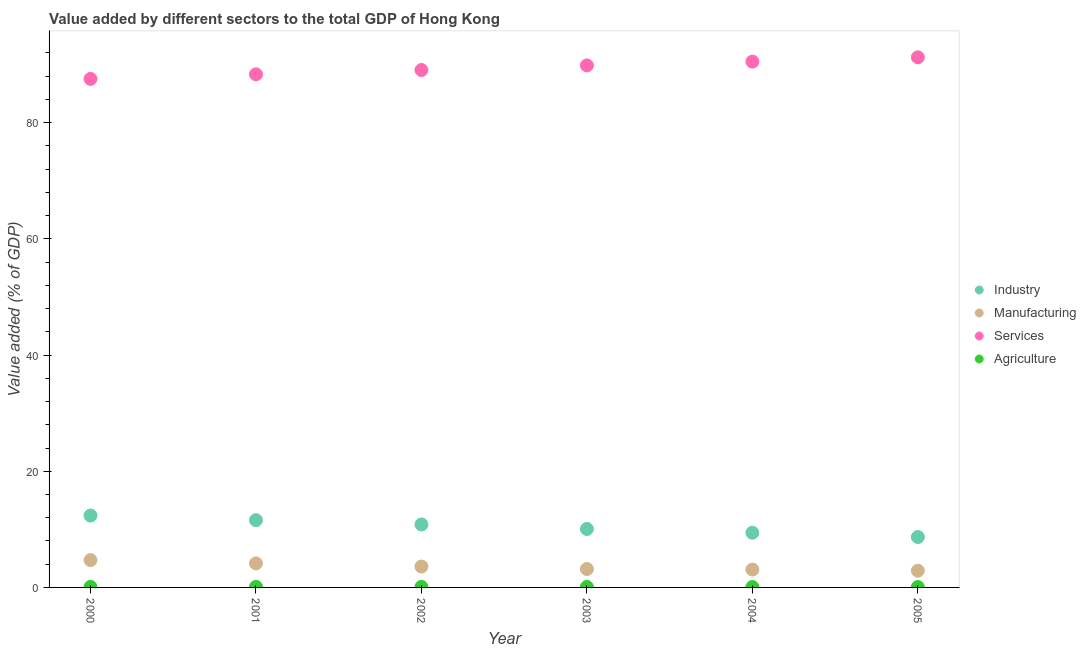Is the number of dotlines equal to the number of legend labels?
Offer a terse response. Yes. What is the value added by manufacturing sector in 2005?
Your answer should be compact. 2.88. Across all years, what is the maximum value added by services sector?
Your answer should be very brief. 91.26. Across all years, what is the minimum value added by agricultural sector?
Keep it short and to the point. 0.07. In which year was the value added by industrial sector maximum?
Give a very brief answer. 2000. What is the total value added by services sector in the graph?
Keep it short and to the point. 536.57. What is the difference between the value added by agricultural sector in 2001 and that in 2003?
Your answer should be compact. 0.01. What is the difference between the value added by industrial sector in 2002 and the value added by manufacturing sector in 2005?
Provide a short and direct response. 7.96. What is the average value added by services sector per year?
Keep it short and to the point. 89.43. In the year 2005, what is the difference between the value added by services sector and value added by manufacturing sector?
Your response must be concise. 88.38. In how many years, is the value added by services sector greater than 16 %?
Your answer should be compact. 6. What is the ratio of the value added by agricultural sector in 2000 to that in 2002?
Your response must be concise. 1. Is the difference between the value added by agricultural sector in 2003 and 2005 greater than the difference between the value added by manufacturing sector in 2003 and 2005?
Provide a succinct answer. No. What is the difference between the highest and the second highest value added by manufacturing sector?
Your answer should be compact. 0.56. What is the difference between the highest and the lowest value added by manufacturing sector?
Make the answer very short. 1.82. Does the value added by agricultural sector monotonically increase over the years?
Your response must be concise. No. Is the value added by manufacturing sector strictly greater than the value added by industrial sector over the years?
Give a very brief answer. No. How many dotlines are there?
Ensure brevity in your answer.  4. What is the difference between two consecutive major ticks on the Y-axis?
Your answer should be very brief. 20. Does the graph contain any zero values?
Offer a terse response. No. Where does the legend appear in the graph?
Provide a succinct answer. Center right. What is the title of the graph?
Provide a succinct answer. Value added by different sectors to the total GDP of Hong Kong. What is the label or title of the X-axis?
Provide a short and direct response. Year. What is the label or title of the Y-axis?
Offer a terse response. Value added (% of GDP). What is the Value added (% of GDP) in Industry in 2000?
Your answer should be very brief. 12.37. What is the Value added (% of GDP) in Manufacturing in 2000?
Ensure brevity in your answer.  4.7. What is the Value added (% of GDP) in Services in 2000?
Your answer should be compact. 87.54. What is the Value added (% of GDP) of Agriculture in 2000?
Provide a short and direct response. 0.09. What is the Value added (% of GDP) of Industry in 2001?
Offer a terse response. 11.58. What is the Value added (% of GDP) of Manufacturing in 2001?
Your answer should be compact. 4.14. What is the Value added (% of GDP) in Services in 2001?
Make the answer very short. 88.33. What is the Value added (% of GDP) in Agriculture in 2001?
Give a very brief answer. 0.09. What is the Value added (% of GDP) of Industry in 2002?
Give a very brief answer. 10.84. What is the Value added (% of GDP) in Manufacturing in 2002?
Give a very brief answer. 3.6. What is the Value added (% of GDP) of Services in 2002?
Give a very brief answer. 89.07. What is the Value added (% of GDP) of Agriculture in 2002?
Your answer should be very brief. 0.09. What is the Value added (% of GDP) in Industry in 2003?
Give a very brief answer. 10.06. What is the Value added (% of GDP) of Manufacturing in 2003?
Your answer should be compact. 3.17. What is the Value added (% of GDP) of Services in 2003?
Provide a short and direct response. 89.86. What is the Value added (% of GDP) of Agriculture in 2003?
Your answer should be compact. 0.08. What is the Value added (% of GDP) in Industry in 2004?
Provide a short and direct response. 9.41. What is the Value added (% of GDP) of Manufacturing in 2004?
Your response must be concise. 3.07. What is the Value added (% of GDP) of Services in 2004?
Give a very brief answer. 90.51. What is the Value added (% of GDP) of Agriculture in 2004?
Your response must be concise. 0.08. What is the Value added (% of GDP) of Industry in 2005?
Offer a terse response. 8.67. What is the Value added (% of GDP) in Manufacturing in 2005?
Offer a very short reply. 2.88. What is the Value added (% of GDP) in Services in 2005?
Provide a succinct answer. 91.26. What is the Value added (% of GDP) of Agriculture in 2005?
Your answer should be compact. 0.07. Across all years, what is the maximum Value added (% of GDP) of Industry?
Make the answer very short. 12.37. Across all years, what is the maximum Value added (% of GDP) of Manufacturing?
Your response must be concise. 4.7. Across all years, what is the maximum Value added (% of GDP) of Services?
Keep it short and to the point. 91.26. Across all years, what is the maximum Value added (% of GDP) of Agriculture?
Give a very brief answer. 0.09. Across all years, what is the minimum Value added (% of GDP) of Industry?
Ensure brevity in your answer.  8.67. Across all years, what is the minimum Value added (% of GDP) of Manufacturing?
Ensure brevity in your answer.  2.88. Across all years, what is the minimum Value added (% of GDP) in Services?
Your answer should be compact. 87.54. Across all years, what is the minimum Value added (% of GDP) in Agriculture?
Your answer should be very brief. 0.07. What is the total Value added (% of GDP) in Industry in the graph?
Keep it short and to the point. 62.94. What is the total Value added (% of GDP) of Manufacturing in the graph?
Keep it short and to the point. 21.56. What is the total Value added (% of GDP) in Services in the graph?
Give a very brief answer. 536.57. What is the total Value added (% of GDP) of Agriculture in the graph?
Your answer should be compact. 0.49. What is the difference between the Value added (% of GDP) of Industry in 2000 and that in 2001?
Keep it short and to the point. 0.79. What is the difference between the Value added (% of GDP) of Manufacturing in 2000 and that in 2001?
Your answer should be very brief. 0.56. What is the difference between the Value added (% of GDP) in Services in 2000 and that in 2001?
Provide a succinct answer. -0.79. What is the difference between the Value added (% of GDP) of Agriculture in 2000 and that in 2001?
Offer a very short reply. -0. What is the difference between the Value added (% of GDP) of Industry in 2000 and that in 2002?
Offer a terse response. 1.53. What is the difference between the Value added (% of GDP) of Manufacturing in 2000 and that in 2002?
Keep it short and to the point. 1.1. What is the difference between the Value added (% of GDP) of Services in 2000 and that in 2002?
Offer a very short reply. -1.53. What is the difference between the Value added (% of GDP) in Agriculture in 2000 and that in 2002?
Your response must be concise. -0. What is the difference between the Value added (% of GDP) of Industry in 2000 and that in 2003?
Offer a terse response. 2.31. What is the difference between the Value added (% of GDP) of Manufacturing in 2000 and that in 2003?
Provide a succinct answer. 1.53. What is the difference between the Value added (% of GDP) in Services in 2000 and that in 2003?
Your answer should be very brief. -2.32. What is the difference between the Value added (% of GDP) in Agriculture in 2000 and that in 2003?
Keep it short and to the point. 0.01. What is the difference between the Value added (% of GDP) in Industry in 2000 and that in 2004?
Your response must be concise. 2.96. What is the difference between the Value added (% of GDP) of Manufacturing in 2000 and that in 2004?
Your answer should be compact. 1.63. What is the difference between the Value added (% of GDP) of Services in 2000 and that in 2004?
Make the answer very short. -2.97. What is the difference between the Value added (% of GDP) of Agriculture in 2000 and that in 2004?
Offer a very short reply. 0.01. What is the difference between the Value added (% of GDP) in Industry in 2000 and that in 2005?
Keep it short and to the point. 3.7. What is the difference between the Value added (% of GDP) in Manufacturing in 2000 and that in 2005?
Provide a short and direct response. 1.82. What is the difference between the Value added (% of GDP) in Services in 2000 and that in 2005?
Give a very brief answer. -3.72. What is the difference between the Value added (% of GDP) of Agriculture in 2000 and that in 2005?
Give a very brief answer. 0.02. What is the difference between the Value added (% of GDP) in Industry in 2001 and that in 2002?
Your response must be concise. 0.74. What is the difference between the Value added (% of GDP) of Manufacturing in 2001 and that in 2002?
Your response must be concise. 0.54. What is the difference between the Value added (% of GDP) of Services in 2001 and that in 2002?
Your answer should be very brief. -0.74. What is the difference between the Value added (% of GDP) in Agriculture in 2001 and that in 2002?
Provide a succinct answer. 0. What is the difference between the Value added (% of GDP) in Industry in 2001 and that in 2003?
Your response must be concise. 1.52. What is the difference between the Value added (% of GDP) of Manufacturing in 2001 and that in 2003?
Provide a succinct answer. 0.97. What is the difference between the Value added (% of GDP) of Services in 2001 and that in 2003?
Ensure brevity in your answer.  -1.53. What is the difference between the Value added (% of GDP) of Agriculture in 2001 and that in 2003?
Make the answer very short. 0.01. What is the difference between the Value added (% of GDP) in Industry in 2001 and that in 2004?
Provide a short and direct response. 2.17. What is the difference between the Value added (% of GDP) in Manufacturing in 2001 and that in 2004?
Offer a terse response. 1.06. What is the difference between the Value added (% of GDP) of Services in 2001 and that in 2004?
Ensure brevity in your answer.  -2.19. What is the difference between the Value added (% of GDP) in Agriculture in 2001 and that in 2004?
Provide a succinct answer. 0.02. What is the difference between the Value added (% of GDP) in Industry in 2001 and that in 2005?
Your response must be concise. 2.91. What is the difference between the Value added (% of GDP) of Manufacturing in 2001 and that in 2005?
Ensure brevity in your answer.  1.26. What is the difference between the Value added (% of GDP) in Services in 2001 and that in 2005?
Give a very brief answer. -2.93. What is the difference between the Value added (% of GDP) of Agriculture in 2001 and that in 2005?
Keep it short and to the point. 0.02. What is the difference between the Value added (% of GDP) of Industry in 2002 and that in 2003?
Provide a short and direct response. 0.78. What is the difference between the Value added (% of GDP) in Manufacturing in 2002 and that in 2003?
Provide a succinct answer. 0.43. What is the difference between the Value added (% of GDP) of Services in 2002 and that in 2003?
Offer a terse response. -0.79. What is the difference between the Value added (% of GDP) of Agriculture in 2002 and that in 2003?
Provide a short and direct response. 0.01. What is the difference between the Value added (% of GDP) of Industry in 2002 and that in 2004?
Provide a short and direct response. 1.43. What is the difference between the Value added (% of GDP) in Manufacturing in 2002 and that in 2004?
Offer a terse response. 0.52. What is the difference between the Value added (% of GDP) in Services in 2002 and that in 2004?
Provide a succinct answer. -1.44. What is the difference between the Value added (% of GDP) of Agriculture in 2002 and that in 2004?
Give a very brief answer. 0.01. What is the difference between the Value added (% of GDP) of Industry in 2002 and that in 2005?
Your answer should be very brief. 2.17. What is the difference between the Value added (% of GDP) of Manufacturing in 2002 and that in 2005?
Give a very brief answer. 0.72. What is the difference between the Value added (% of GDP) of Services in 2002 and that in 2005?
Give a very brief answer. -2.19. What is the difference between the Value added (% of GDP) in Agriculture in 2002 and that in 2005?
Make the answer very short. 0.02. What is the difference between the Value added (% of GDP) in Industry in 2003 and that in 2004?
Your answer should be very brief. 0.65. What is the difference between the Value added (% of GDP) in Manufacturing in 2003 and that in 2004?
Your answer should be very brief. 0.09. What is the difference between the Value added (% of GDP) in Services in 2003 and that in 2004?
Offer a very short reply. -0.65. What is the difference between the Value added (% of GDP) of Agriculture in 2003 and that in 2004?
Provide a succinct answer. 0. What is the difference between the Value added (% of GDP) in Industry in 2003 and that in 2005?
Your answer should be very brief. 1.39. What is the difference between the Value added (% of GDP) in Manufacturing in 2003 and that in 2005?
Ensure brevity in your answer.  0.29. What is the difference between the Value added (% of GDP) of Services in 2003 and that in 2005?
Keep it short and to the point. -1.4. What is the difference between the Value added (% of GDP) of Agriculture in 2003 and that in 2005?
Offer a very short reply. 0.01. What is the difference between the Value added (% of GDP) in Industry in 2004 and that in 2005?
Your response must be concise. 0.74. What is the difference between the Value added (% of GDP) of Manufacturing in 2004 and that in 2005?
Keep it short and to the point. 0.2. What is the difference between the Value added (% of GDP) in Services in 2004 and that in 2005?
Make the answer very short. -0.74. What is the difference between the Value added (% of GDP) of Agriculture in 2004 and that in 2005?
Provide a succinct answer. 0.01. What is the difference between the Value added (% of GDP) in Industry in 2000 and the Value added (% of GDP) in Manufacturing in 2001?
Ensure brevity in your answer.  8.23. What is the difference between the Value added (% of GDP) in Industry in 2000 and the Value added (% of GDP) in Services in 2001?
Give a very brief answer. -75.96. What is the difference between the Value added (% of GDP) in Industry in 2000 and the Value added (% of GDP) in Agriculture in 2001?
Ensure brevity in your answer.  12.28. What is the difference between the Value added (% of GDP) in Manufacturing in 2000 and the Value added (% of GDP) in Services in 2001?
Your answer should be compact. -83.63. What is the difference between the Value added (% of GDP) of Manufacturing in 2000 and the Value added (% of GDP) of Agriculture in 2001?
Your answer should be compact. 4.61. What is the difference between the Value added (% of GDP) in Services in 2000 and the Value added (% of GDP) in Agriculture in 2001?
Give a very brief answer. 87.45. What is the difference between the Value added (% of GDP) of Industry in 2000 and the Value added (% of GDP) of Manufacturing in 2002?
Keep it short and to the point. 8.78. What is the difference between the Value added (% of GDP) in Industry in 2000 and the Value added (% of GDP) in Services in 2002?
Offer a very short reply. -76.7. What is the difference between the Value added (% of GDP) of Industry in 2000 and the Value added (% of GDP) of Agriculture in 2002?
Ensure brevity in your answer.  12.28. What is the difference between the Value added (% of GDP) in Manufacturing in 2000 and the Value added (% of GDP) in Services in 2002?
Your response must be concise. -84.37. What is the difference between the Value added (% of GDP) in Manufacturing in 2000 and the Value added (% of GDP) in Agriculture in 2002?
Keep it short and to the point. 4.61. What is the difference between the Value added (% of GDP) of Services in 2000 and the Value added (% of GDP) of Agriculture in 2002?
Give a very brief answer. 87.45. What is the difference between the Value added (% of GDP) in Industry in 2000 and the Value added (% of GDP) in Manufacturing in 2003?
Keep it short and to the point. 9.2. What is the difference between the Value added (% of GDP) of Industry in 2000 and the Value added (% of GDP) of Services in 2003?
Make the answer very short. -77.49. What is the difference between the Value added (% of GDP) of Industry in 2000 and the Value added (% of GDP) of Agriculture in 2003?
Your answer should be very brief. 12.29. What is the difference between the Value added (% of GDP) in Manufacturing in 2000 and the Value added (% of GDP) in Services in 2003?
Offer a very short reply. -85.16. What is the difference between the Value added (% of GDP) in Manufacturing in 2000 and the Value added (% of GDP) in Agriculture in 2003?
Provide a short and direct response. 4.62. What is the difference between the Value added (% of GDP) of Services in 2000 and the Value added (% of GDP) of Agriculture in 2003?
Keep it short and to the point. 87.46. What is the difference between the Value added (% of GDP) of Industry in 2000 and the Value added (% of GDP) of Manufacturing in 2004?
Provide a short and direct response. 9.3. What is the difference between the Value added (% of GDP) of Industry in 2000 and the Value added (% of GDP) of Services in 2004?
Ensure brevity in your answer.  -78.14. What is the difference between the Value added (% of GDP) of Industry in 2000 and the Value added (% of GDP) of Agriculture in 2004?
Your answer should be very brief. 12.3. What is the difference between the Value added (% of GDP) of Manufacturing in 2000 and the Value added (% of GDP) of Services in 2004?
Keep it short and to the point. -85.81. What is the difference between the Value added (% of GDP) of Manufacturing in 2000 and the Value added (% of GDP) of Agriculture in 2004?
Your answer should be very brief. 4.63. What is the difference between the Value added (% of GDP) in Services in 2000 and the Value added (% of GDP) in Agriculture in 2004?
Offer a terse response. 87.46. What is the difference between the Value added (% of GDP) of Industry in 2000 and the Value added (% of GDP) of Manufacturing in 2005?
Your answer should be compact. 9.49. What is the difference between the Value added (% of GDP) in Industry in 2000 and the Value added (% of GDP) in Services in 2005?
Provide a succinct answer. -78.89. What is the difference between the Value added (% of GDP) in Industry in 2000 and the Value added (% of GDP) in Agriculture in 2005?
Your answer should be very brief. 12.3. What is the difference between the Value added (% of GDP) of Manufacturing in 2000 and the Value added (% of GDP) of Services in 2005?
Provide a short and direct response. -86.56. What is the difference between the Value added (% of GDP) of Manufacturing in 2000 and the Value added (% of GDP) of Agriculture in 2005?
Provide a short and direct response. 4.63. What is the difference between the Value added (% of GDP) in Services in 2000 and the Value added (% of GDP) in Agriculture in 2005?
Keep it short and to the point. 87.47. What is the difference between the Value added (% of GDP) in Industry in 2001 and the Value added (% of GDP) in Manufacturing in 2002?
Keep it short and to the point. 7.98. What is the difference between the Value added (% of GDP) in Industry in 2001 and the Value added (% of GDP) in Services in 2002?
Provide a short and direct response. -77.49. What is the difference between the Value added (% of GDP) of Industry in 2001 and the Value added (% of GDP) of Agriculture in 2002?
Make the answer very short. 11.49. What is the difference between the Value added (% of GDP) in Manufacturing in 2001 and the Value added (% of GDP) in Services in 2002?
Ensure brevity in your answer.  -84.93. What is the difference between the Value added (% of GDP) of Manufacturing in 2001 and the Value added (% of GDP) of Agriculture in 2002?
Offer a very short reply. 4.05. What is the difference between the Value added (% of GDP) in Services in 2001 and the Value added (% of GDP) in Agriculture in 2002?
Provide a succinct answer. 88.24. What is the difference between the Value added (% of GDP) of Industry in 2001 and the Value added (% of GDP) of Manufacturing in 2003?
Offer a terse response. 8.41. What is the difference between the Value added (% of GDP) in Industry in 2001 and the Value added (% of GDP) in Services in 2003?
Offer a terse response. -78.28. What is the difference between the Value added (% of GDP) of Industry in 2001 and the Value added (% of GDP) of Agriculture in 2003?
Provide a succinct answer. 11.5. What is the difference between the Value added (% of GDP) in Manufacturing in 2001 and the Value added (% of GDP) in Services in 2003?
Your answer should be compact. -85.72. What is the difference between the Value added (% of GDP) in Manufacturing in 2001 and the Value added (% of GDP) in Agriculture in 2003?
Offer a terse response. 4.06. What is the difference between the Value added (% of GDP) of Services in 2001 and the Value added (% of GDP) of Agriculture in 2003?
Offer a terse response. 88.25. What is the difference between the Value added (% of GDP) of Industry in 2001 and the Value added (% of GDP) of Manufacturing in 2004?
Provide a succinct answer. 8.51. What is the difference between the Value added (% of GDP) of Industry in 2001 and the Value added (% of GDP) of Services in 2004?
Give a very brief answer. -78.93. What is the difference between the Value added (% of GDP) of Industry in 2001 and the Value added (% of GDP) of Agriculture in 2004?
Provide a succinct answer. 11.5. What is the difference between the Value added (% of GDP) of Manufacturing in 2001 and the Value added (% of GDP) of Services in 2004?
Your response must be concise. -86.38. What is the difference between the Value added (% of GDP) in Manufacturing in 2001 and the Value added (% of GDP) in Agriculture in 2004?
Ensure brevity in your answer.  4.06. What is the difference between the Value added (% of GDP) of Services in 2001 and the Value added (% of GDP) of Agriculture in 2004?
Your response must be concise. 88.25. What is the difference between the Value added (% of GDP) of Industry in 2001 and the Value added (% of GDP) of Manufacturing in 2005?
Your response must be concise. 8.7. What is the difference between the Value added (% of GDP) of Industry in 2001 and the Value added (% of GDP) of Services in 2005?
Give a very brief answer. -79.68. What is the difference between the Value added (% of GDP) in Industry in 2001 and the Value added (% of GDP) in Agriculture in 2005?
Your answer should be very brief. 11.51. What is the difference between the Value added (% of GDP) in Manufacturing in 2001 and the Value added (% of GDP) in Services in 2005?
Your answer should be very brief. -87.12. What is the difference between the Value added (% of GDP) of Manufacturing in 2001 and the Value added (% of GDP) of Agriculture in 2005?
Your response must be concise. 4.07. What is the difference between the Value added (% of GDP) in Services in 2001 and the Value added (% of GDP) in Agriculture in 2005?
Provide a short and direct response. 88.26. What is the difference between the Value added (% of GDP) of Industry in 2002 and the Value added (% of GDP) of Manufacturing in 2003?
Your response must be concise. 7.67. What is the difference between the Value added (% of GDP) in Industry in 2002 and the Value added (% of GDP) in Services in 2003?
Your answer should be very brief. -79.02. What is the difference between the Value added (% of GDP) of Industry in 2002 and the Value added (% of GDP) of Agriculture in 2003?
Give a very brief answer. 10.76. What is the difference between the Value added (% of GDP) in Manufacturing in 2002 and the Value added (% of GDP) in Services in 2003?
Provide a short and direct response. -86.27. What is the difference between the Value added (% of GDP) in Manufacturing in 2002 and the Value added (% of GDP) in Agriculture in 2003?
Keep it short and to the point. 3.52. What is the difference between the Value added (% of GDP) of Services in 2002 and the Value added (% of GDP) of Agriculture in 2003?
Provide a succinct answer. 88.99. What is the difference between the Value added (% of GDP) of Industry in 2002 and the Value added (% of GDP) of Manufacturing in 2004?
Give a very brief answer. 7.77. What is the difference between the Value added (% of GDP) in Industry in 2002 and the Value added (% of GDP) in Services in 2004?
Your answer should be compact. -79.67. What is the difference between the Value added (% of GDP) in Industry in 2002 and the Value added (% of GDP) in Agriculture in 2004?
Give a very brief answer. 10.77. What is the difference between the Value added (% of GDP) of Manufacturing in 2002 and the Value added (% of GDP) of Services in 2004?
Give a very brief answer. -86.92. What is the difference between the Value added (% of GDP) in Manufacturing in 2002 and the Value added (% of GDP) in Agriculture in 2004?
Your answer should be compact. 3.52. What is the difference between the Value added (% of GDP) in Services in 2002 and the Value added (% of GDP) in Agriculture in 2004?
Offer a very short reply. 88.99. What is the difference between the Value added (% of GDP) in Industry in 2002 and the Value added (% of GDP) in Manufacturing in 2005?
Keep it short and to the point. 7.96. What is the difference between the Value added (% of GDP) in Industry in 2002 and the Value added (% of GDP) in Services in 2005?
Your answer should be very brief. -80.42. What is the difference between the Value added (% of GDP) of Industry in 2002 and the Value added (% of GDP) of Agriculture in 2005?
Your answer should be compact. 10.77. What is the difference between the Value added (% of GDP) of Manufacturing in 2002 and the Value added (% of GDP) of Services in 2005?
Offer a very short reply. -87.66. What is the difference between the Value added (% of GDP) of Manufacturing in 2002 and the Value added (% of GDP) of Agriculture in 2005?
Your answer should be compact. 3.53. What is the difference between the Value added (% of GDP) in Services in 2002 and the Value added (% of GDP) in Agriculture in 2005?
Provide a short and direct response. 89. What is the difference between the Value added (% of GDP) of Industry in 2003 and the Value added (% of GDP) of Manufacturing in 2004?
Your response must be concise. 6.99. What is the difference between the Value added (% of GDP) in Industry in 2003 and the Value added (% of GDP) in Services in 2004?
Your answer should be compact. -80.45. What is the difference between the Value added (% of GDP) of Industry in 2003 and the Value added (% of GDP) of Agriculture in 2004?
Provide a short and direct response. 9.99. What is the difference between the Value added (% of GDP) in Manufacturing in 2003 and the Value added (% of GDP) in Services in 2004?
Make the answer very short. -87.34. What is the difference between the Value added (% of GDP) of Manufacturing in 2003 and the Value added (% of GDP) of Agriculture in 2004?
Make the answer very short. 3.09. What is the difference between the Value added (% of GDP) of Services in 2003 and the Value added (% of GDP) of Agriculture in 2004?
Ensure brevity in your answer.  89.79. What is the difference between the Value added (% of GDP) of Industry in 2003 and the Value added (% of GDP) of Manufacturing in 2005?
Give a very brief answer. 7.18. What is the difference between the Value added (% of GDP) in Industry in 2003 and the Value added (% of GDP) in Services in 2005?
Provide a short and direct response. -81.19. What is the difference between the Value added (% of GDP) in Industry in 2003 and the Value added (% of GDP) in Agriculture in 2005?
Give a very brief answer. 9.99. What is the difference between the Value added (% of GDP) in Manufacturing in 2003 and the Value added (% of GDP) in Services in 2005?
Give a very brief answer. -88.09. What is the difference between the Value added (% of GDP) in Manufacturing in 2003 and the Value added (% of GDP) in Agriculture in 2005?
Offer a terse response. 3.1. What is the difference between the Value added (% of GDP) in Services in 2003 and the Value added (% of GDP) in Agriculture in 2005?
Make the answer very short. 89.79. What is the difference between the Value added (% of GDP) in Industry in 2004 and the Value added (% of GDP) in Manufacturing in 2005?
Your answer should be very brief. 6.53. What is the difference between the Value added (% of GDP) of Industry in 2004 and the Value added (% of GDP) of Services in 2005?
Your answer should be compact. -81.85. What is the difference between the Value added (% of GDP) in Industry in 2004 and the Value added (% of GDP) in Agriculture in 2005?
Provide a short and direct response. 9.34. What is the difference between the Value added (% of GDP) of Manufacturing in 2004 and the Value added (% of GDP) of Services in 2005?
Give a very brief answer. -88.18. What is the difference between the Value added (% of GDP) in Manufacturing in 2004 and the Value added (% of GDP) in Agriculture in 2005?
Provide a short and direct response. 3.01. What is the difference between the Value added (% of GDP) in Services in 2004 and the Value added (% of GDP) in Agriculture in 2005?
Your response must be concise. 90.44. What is the average Value added (% of GDP) of Industry per year?
Your answer should be compact. 10.49. What is the average Value added (% of GDP) in Manufacturing per year?
Keep it short and to the point. 3.59. What is the average Value added (% of GDP) in Services per year?
Provide a short and direct response. 89.43. What is the average Value added (% of GDP) of Agriculture per year?
Give a very brief answer. 0.08. In the year 2000, what is the difference between the Value added (% of GDP) in Industry and Value added (% of GDP) in Manufacturing?
Provide a short and direct response. 7.67. In the year 2000, what is the difference between the Value added (% of GDP) in Industry and Value added (% of GDP) in Services?
Your response must be concise. -75.17. In the year 2000, what is the difference between the Value added (% of GDP) of Industry and Value added (% of GDP) of Agriculture?
Keep it short and to the point. 12.28. In the year 2000, what is the difference between the Value added (% of GDP) of Manufacturing and Value added (% of GDP) of Services?
Provide a short and direct response. -82.84. In the year 2000, what is the difference between the Value added (% of GDP) of Manufacturing and Value added (% of GDP) of Agriculture?
Your answer should be very brief. 4.61. In the year 2000, what is the difference between the Value added (% of GDP) of Services and Value added (% of GDP) of Agriculture?
Offer a very short reply. 87.45. In the year 2001, what is the difference between the Value added (% of GDP) of Industry and Value added (% of GDP) of Manufacturing?
Offer a terse response. 7.44. In the year 2001, what is the difference between the Value added (% of GDP) of Industry and Value added (% of GDP) of Services?
Keep it short and to the point. -76.75. In the year 2001, what is the difference between the Value added (% of GDP) in Industry and Value added (% of GDP) in Agriculture?
Give a very brief answer. 11.49. In the year 2001, what is the difference between the Value added (% of GDP) of Manufacturing and Value added (% of GDP) of Services?
Offer a terse response. -84.19. In the year 2001, what is the difference between the Value added (% of GDP) of Manufacturing and Value added (% of GDP) of Agriculture?
Offer a terse response. 4.05. In the year 2001, what is the difference between the Value added (% of GDP) of Services and Value added (% of GDP) of Agriculture?
Ensure brevity in your answer.  88.24. In the year 2002, what is the difference between the Value added (% of GDP) of Industry and Value added (% of GDP) of Manufacturing?
Keep it short and to the point. 7.24. In the year 2002, what is the difference between the Value added (% of GDP) of Industry and Value added (% of GDP) of Services?
Your response must be concise. -78.23. In the year 2002, what is the difference between the Value added (% of GDP) in Industry and Value added (% of GDP) in Agriculture?
Your answer should be compact. 10.75. In the year 2002, what is the difference between the Value added (% of GDP) of Manufacturing and Value added (% of GDP) of Services?
Provide a short and direct response. -85.47. In the year 2002, what is the difference between the Value added (% of GDP) of Manufacturing and Value added (% of GDP) of Agriculture?
Offer a very short reply. 3.51. In the year 2002, what is the difference between the Value added (% of GDP) in Services and Value added (% of GDP) in Agriculture?
Offer a terse response. 88.98. In the year 2003, what is the difference between the Value added (% of GDP) of Industry and Value added (% of GDP) of Manufacturing?
Provide a short and direct response. 6.89. In the year 2003, what is the difference between the Value added (% of GDP) of Industry and Value added (% of GDP) of Services?
Give a very brief answer. -79.8. In the year 2003, what is the difference between the Value added (% of GDP) in Industry and Value added (% of GDP) in Agriculture?
Make the answer very short. 9.99. In the year 2003, what is the difference between the Value added (% of GDP) in Manufacturing and Value added (% of GDP) in Services?
Your response must be concise. -86.69. In the year 2003, what is the difference between the Value added (% of GDP) in Manufacturing and Value added (% of GDP) in Agriculture?
Keep it short and to the point. 3.09. In the year 2003, what is the difference between the Value added (% of GDP) of Services and Value added (% of GDP) of Agriculture?
Offer a terse response. 89.78. In the year 2004, what is the difference between the Value added (% of GDP) in Industry and Value added (% of GDP) in Manufacturing?
Your answer should be compact. 6.34. In the year 2004, what is the difference between the Value added (% of GDP) in Industry and Value added (% of GDP) in Services?
Provide a succinct answer. -81.1. In the year 2004, what is the difference between the Value added (% of GDP) of Industry and Value added (% of GDP) of Agriculture?
Your response must be concise. 9.34. In the year 2004, what is the difference between the Value added (% of GDP) of Manufacturing and Value added (% of GDP) of Services?
Provide a succinct answer. -87.44. In the year 2004, what is the difference between the Value added (% of GDP) of Manufacturing and Value added (% of GDP) of Agriculture?
Make the answer very short. 3. In the year 2004, what is the difference between the Value added (% of GDP) in Services and Value added (% of GDP) in Agriculture?
Make the answer very short. 90.44. In the year 2005, what is the difference between the Value added (% of GDP) of Industry and Value added (% of GDP) of Manufacturing?
Offer a terse response. 5.79. In the year 2005, what is the difference between the Value added (% of GDP) of Industry and Value added (% of GDP) of Services?
Provide a succinct answer. -82.58. In the year 2005, what is the difference between the Value added (% of GDP) of Industry and Value added (% of GDP) of Agriculture?
Offer a terse response. 8.61. In the year 2005, what is the difference between the Value added (% of GDP) of Manufacturing and Value added (% of GDP) of Services?
Ensure brevity in your answer.  -88.38. In the year 2005, what is the difference between the Value added (% of GDP) of Manufacturing and Value added (% of GDP) of Agriculture?
Offer a very short reply. 2.81. In the year 2005, what is the difference between the Value added (% of GDP) of Services and Value added (% of GDP) of Agriculture?
Offer a very short reply. 91.19. What is the ratio of the Value added (% of GDP) of Industry in 2000 to that in 2001?
Make the answer very short. 1.07. What is the ratio of the Value added (% of GDP) in Manufacturing in 2000 to that in 2001?
Make the answer very short. 1.14. What is the ratio of the Value added (% of GDP) of Agriculture in 2000 to that in 2001?
Make the answer very short. 0.98. What is the ratio of the Value added (% of GDP) of Industry in 2000 to that in 2002?
Keep it short and to the point. 1.14. What is the ratio of the Value added (% of GDP) of Manufacturing in 2000 to that in 2002?
Give a very brief answer. 1.31. What is the ratio of the Value added (% of GDP) in Services in 2000 to that in 2002?
Your answer should be compact. 0.98. What is the ratio of the Value added (% of GDP) of Agriculture in 2000 to that in 2002?
Give a very brief answer. 1. What is the ratio of the Value added (% of GDP) in Industry in 2000 to that in 2003?
Provide a succinct answer. 1.23. What is the ratio of the Value added (% of GDP) in Manufacturing in 2000 to that in 2003?
Provide a short and direct response. 1.48. What is the ratio of the Value added (% of GDP) in Services in 2000 to that in 2003?
Your answer should be very brief. 0.97. What is the ratio of the Value added (% of GDP) in Agriculture in 2000 to that in 2003?
Offer a very short reply. 1.17. What is the ratio of the Value added (% of GDP) in Industry in 2000 to that in 2004?
Offer a very short reply. 1.31. What is the ratio of the Value added (% of GDP) in Manufacturing in 2000 to that in 2004?
Keep it short and to the point. 1.53. What is the ratio of the Value added (% of GDP) of Services in 2000 to that in 2004?
Keep it short and to the point. 0.97. What is the ratio of the Value added (% of GDP) in Agriculture in 2000 to that in 2004?
Your answer should be very brief. 1.19. What is the ratio of the Value added (% of GDP) of Industry in 2000 to that in 2005?
Your answer should be compact. 1.43. What is the ratio of the Value added (% of GDP) of Manufacturing in 2000 to that in 2005?
Provide a short and direct response. 1.63. What is the ratio of the Value added (% of GDP) of Services in 2000 to that in 2005?
Offer a terse response. 0.96. What is the ratio of the Value added (% of GDP) in Agriculture in 2000 to that in 2005?
Offer a terse response. 1.29. What is the ratio of the Value added (% of GDP) in Industry in 2001 to that in 2002?
Your answer should be compact. 1.07. What is the ratio of the Value added (% of GDP) of Manufacturing in 2001 to that in 2002?
Your answer should be very brief. 1.15. What is the ratio of the Value added (% of GDP) of Services in 2001 to that in 2002?
Your response must be concise. 0.99. What is the ratio of the Value added (% of GDP) in Agriculture in 2001 to that in 2002?
Your response must be concise. 1.02. What is the ratio of the Value added (% of GDP) in Industry in 2001 to that in 2003?
Your answer should be very brief. 1.15. What is the ratio of the Value added (% of GDP) in Manufacturing in 2001 to that in 2003?
Provide a short and direct response. 1.31. What is the ratio of the Value added (% of GDP) of Agriculture in 2001 to that in 2003?
Offer a terse response. 1.19. What is the ratio of the Value added (% of GDP) of Industry in 2001 to that in 2004?
Your answer should be compact. 1.23. What is the ratio of the Value added (% of GDP) in Manufacturing in 2001 to that in 2004?
Your answer should be compact. 1.35. What is the ratio of the Value added (% of GDP) of Services in 2001 to that in 2004?
Give a very brief answer. 0.98. What is the ratio of the Value added (% of GDP) of Agriculture in 2001 to that in 2004?
Offer a terse response. 1.22. What is the ratio of the Value added (% of GDP) in Industry in 2001 to that in 2005?
Your response must be concise. 1.33. What is the ratio of the Value added (% of GDP) of Manufacturing in 2001 to that in 2005?
Give a very brief answer. 1.44. What is the ratio of the Value added (% of GDP) of Services in 2001 to that in 2005?
Your answer should be compact. 0.97. What is the ratio of the Value added (% of GDP) of Agriculture in 2001 to that in 2005?
Your answer should be compact. 1.32. What is the ratio of the Value added (% of GDP) of Industry in 2002 to that in 2003?
Provide a short and direct response. 1.08. What is the ratio of the Value added (% of GDP) in Manufacturing in 2002 to that in 2003?
Provide a succinct answer. 1.13. What is the ratio of the Value added (% of GDP) in Agriculture in 2002 to that in 2003?
Your answer should be compact. 1.17. What is the ratio of the Value added (% of GDP) in Industry in 2002 to that in 2004?
Your response must be concise. 1.15. What is the ratio of the Value added (% of GDP) in Manufacturing in 2002 to that in 2004?
Keep it short and to the point. 1.17. What is the ratio of the Value added (% of GDP) in Services in 2002 to that in 2004?
Provide a short and direct response. 0.98. What is the ratio of the Value added (% of GDP) of Agriculture in 2002 to that in 2004?
Ensure brevity in your answer.  1.2. What is the ratio of the Value added (% of GDP) of Industry in 2002 to that in 2005?
Your response must be concise. 1.25. What is the ratio of the Value added (% of GDP) in Manufacturing in 2002 to that in 2005?
Your answer should be compact. 1.25. What is the ratio of the Value added (% of GDP) of Services in 2002 to that in 2005?
Your answer should be very brief. 0.98. What is the ratio of the Value added (% of GDP) in Agriculture in 2002 to that in 2005?
Provide a succinct answer. 1.3. What is the ratio of the Value added (% of GDP) in Industry in 2003 to that in 2004?
Ensure brevity in your answer.  1.07. What is the ratio of the Value added (% of GDP) in Manufacturing in 2003 to that in 2004?
Provide a succinct answer. 1.03. What is the ratio of the Value added (% of GDP) of Services in 2003 to that in 2004?
Make the answer very short. 0.99. What is the ratio of the Value added (% of GDP) of Agriculture in 2003 to that in 2004?
Provide a short and direct response. 1.02. What is the ratio of the Value added (% of GDP) in Industry in 2003 to that in 2005?
Provide a short and direct response. 1.16. What is the ratio of the Value added (% of GDP) of Manufacturing in 2003 to that in 2005?
Your answer should be compact. 1.1. What is the ratio of the Value added (% of GDP) of Services in 2003 to that in 2005?
Make the answer very short. 0.98. What is the ratio of the Value added (% of GDP) of Agriculture in 2003 to that in 2005?
Ensure brevity in your answer.  1.11. What is the ratio of the Value added (% of GDP) of Industry in 2004 to that in 2005?
Give a very brief answer. 1.08. What is the ratio of the Value added (% of GDP) in Manufacturing in 2004 to that in 2005?
Ensure brevity in your answer.  1.07. What is the ratio of the Value added (% of GDP) of Services in 2004 to that in 2005?
Your answer should be compact. 0.99. What is the ratio of the Value added (% of GDP) in Agriculture in 2004 to that in 2005?
Keep it short and to the point. 1.08. What is the difference between the highest and the second highest Value added (% of GDP) in Industry?
Ensure brevity in your answer.  0.79. What is the difference between the highest and the second highest Value added (% of GDP) in Manufacturing?
Provide a succinct answer. 0.56. What is the difference between the highest and the second highest Value added (% of GDP) of Services?
Offer a very short reply. 0.74. What is the difference between the highest and the second highest Value added (% of GDP) in Agriculture?
Keep it short and to the point. 0. What is the difference between the highest and the lowest Value added (% of GDP) of Industry?
Keep it short and to the point. 3.7. What is the difference between the highest and the lowest Value added (% of GDP) of Manufacturing?
Give a very brief answer. 1.82. What is the difference between the highest and the lowest Value added (% of GDP) of Services?
Your response must be concise. 3.72. What is the difference between the highest and the lowest Value added (% of GDP) in Agriculture?
Offer a terse response. 0.02. 